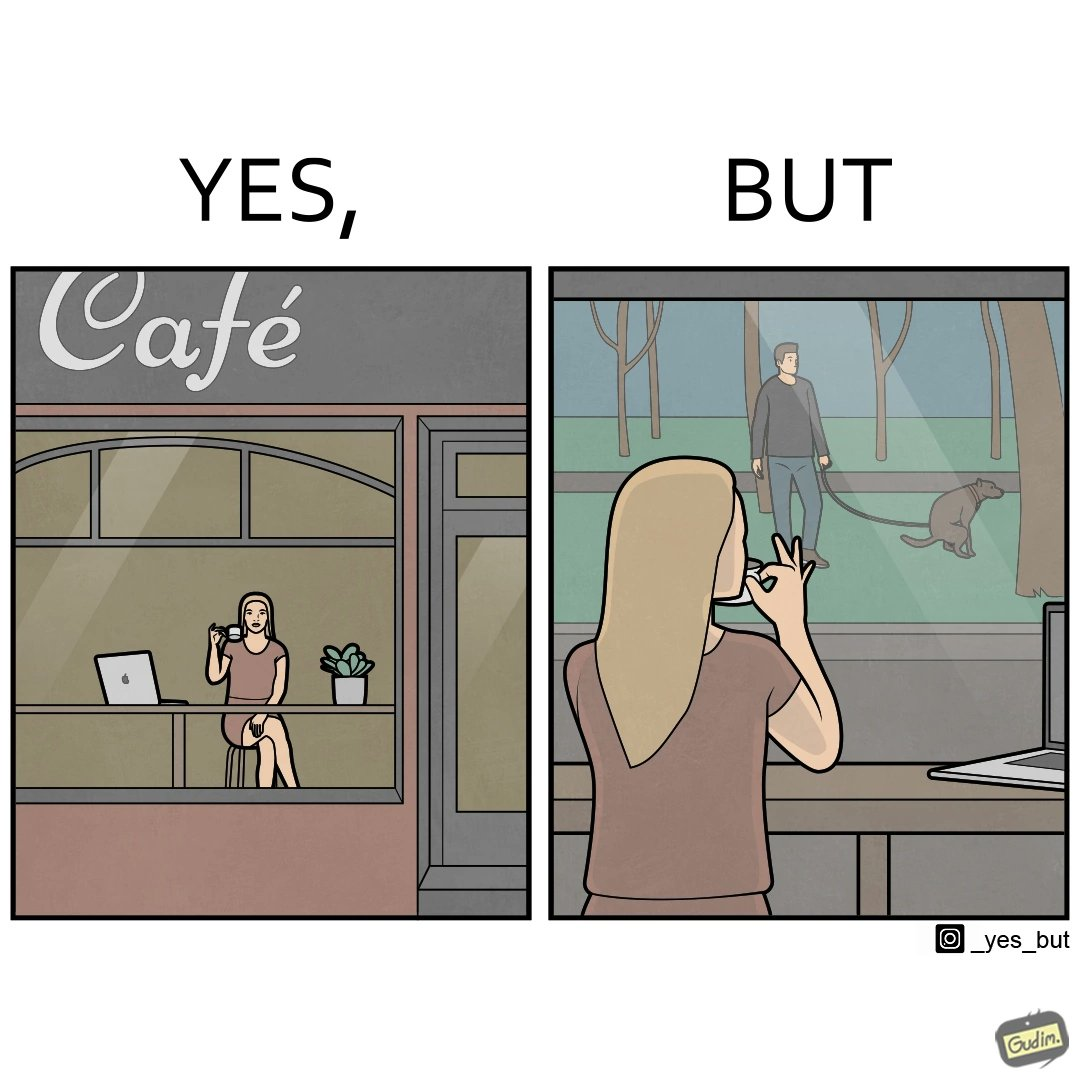Describe the contrast between the left and right parts of this image. In the left part of the image: a woman looking through the window from a cafe while enjoying her drink with working on her laptop In the right part of the image: a woman enjoying her drink and working at laptop while looking outside through the window at a person who is out for getting his dog pooped outside 